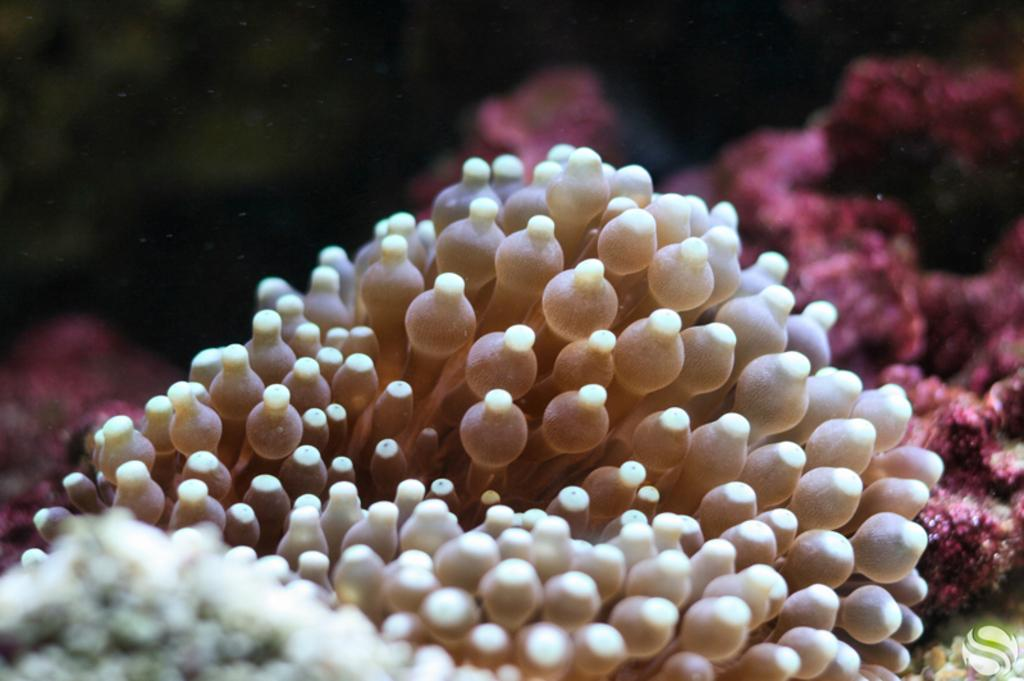What type of animal can be seen in the image? There is a sea animal in the image. What subject is the sea animal teaching in the image? There is no indication in the image that the sea animal is teaching a subject, as animals do not have the ability to teach. 